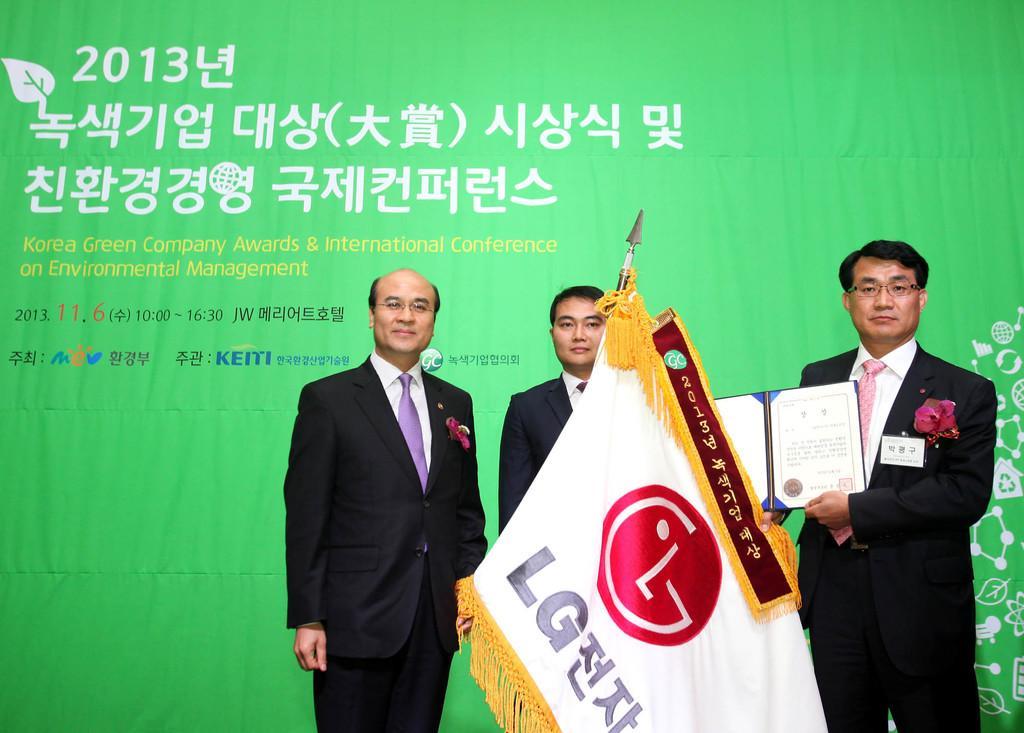Could you give a brief overview of what you see in this image? In the image there are three men standing and holding the pole with flag and momentum in their hands. In the background there is a green poster with something written on it and also there are few images on it. 